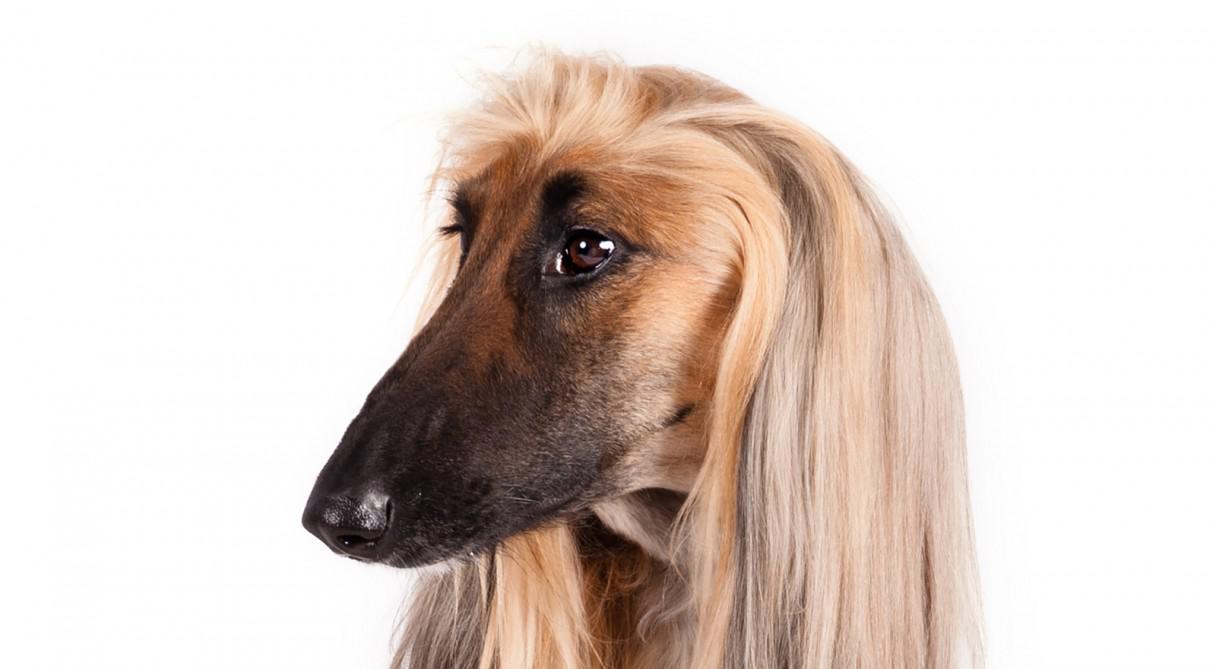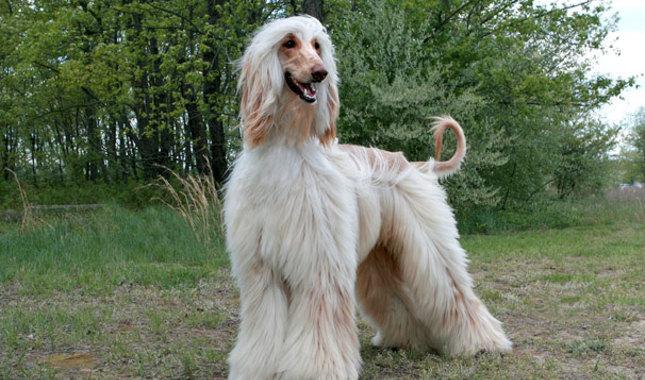The first image is the image on the left, the second image is the image on the right. For the images displayed, is the sentence "The bodies of the dogs in the paired images are turned in the same direction." factually correct? Answer yes or no. No. 